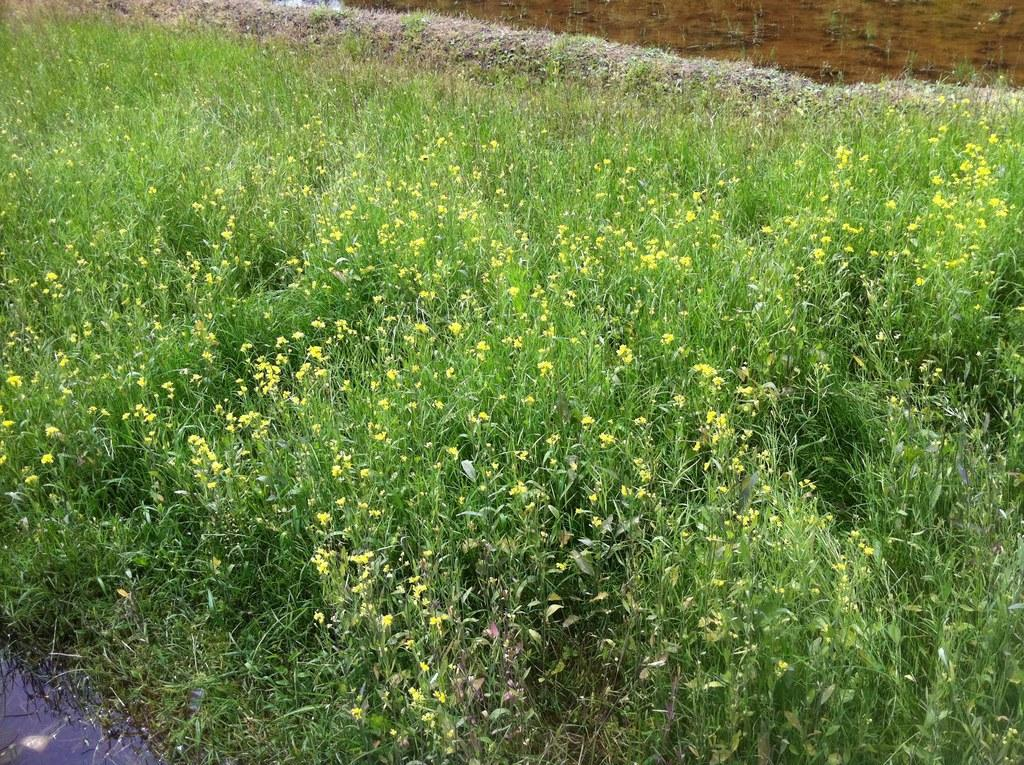What type of plants can be seen in the image? There are flowers in the image. What type of vegetation is present besides flowers? There is grass in the image. What natural element is visible in the image? Water is visible in the image. What type of pump can be seen operating in the image? There is no pump present in the image; it features flowers, grass, and water. 